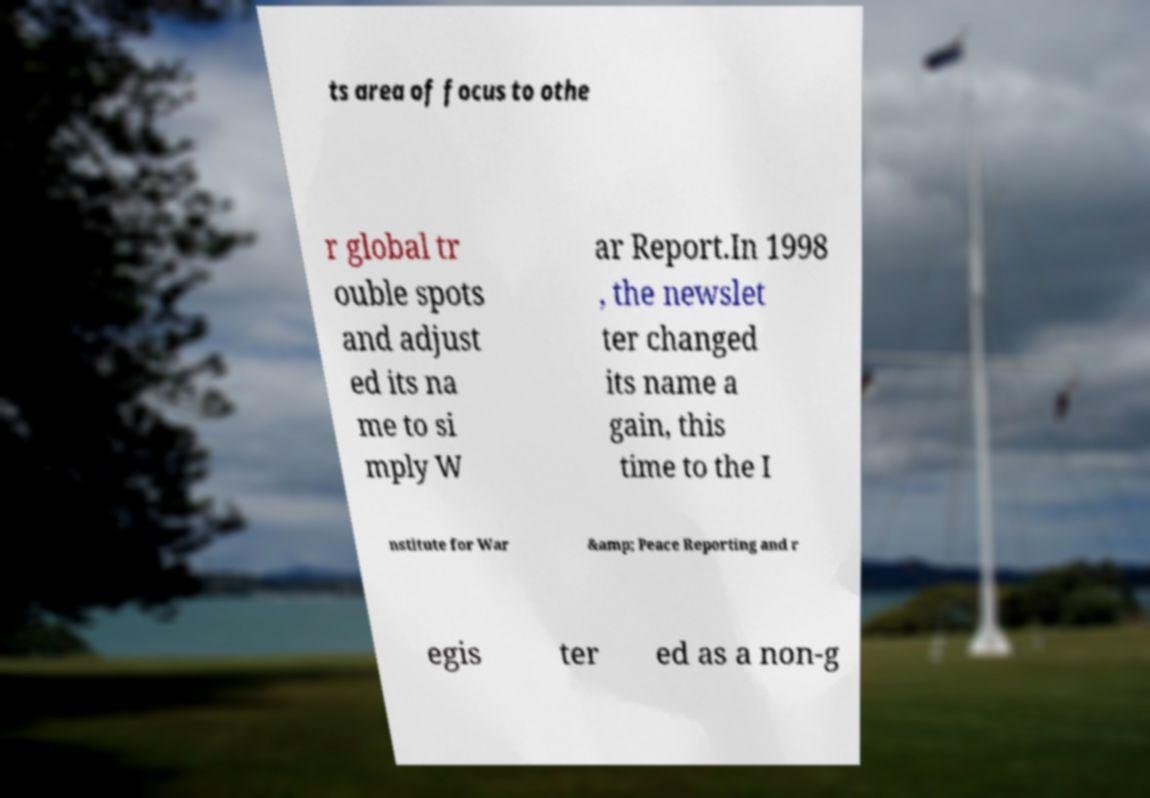What messages or text are displayed in this image? I need them in a readable, typed format. ts area of focus to othe r global tr ouble spots and adjust ed its na me to si mply W ar Report.In 1998 , the newslet ter changed its name a gain, this time to the I nstitute for War &amp; Peace Reporting and r egis ter ed as a non-g 